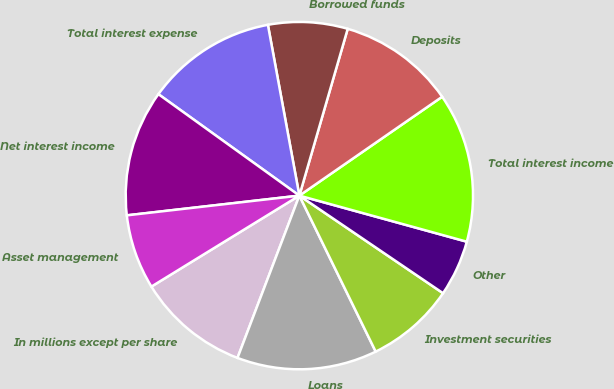Convert chart to OTSL. <chart><loc_0><loc_0><loc_500><loc_500><pie_chart><fcel>In millions except per share<fcel>Loans<fcel>Investment securities<fcel>Other<fcel>Total interest income<fcel>Deposits<fcel>Borrowed funds<fcel>Total interest expense<fcel>Net interest income<fcel>Asset management<nl><fcel>10.43%<fcel>13.04%<fcel>8.26%<fcel>5.22%<fcel>13.91%<fcel>10.87%<fcel>7.39%<fcel>12.17%<fcel>11.74%<fcel>6.96%<nl></chart> 